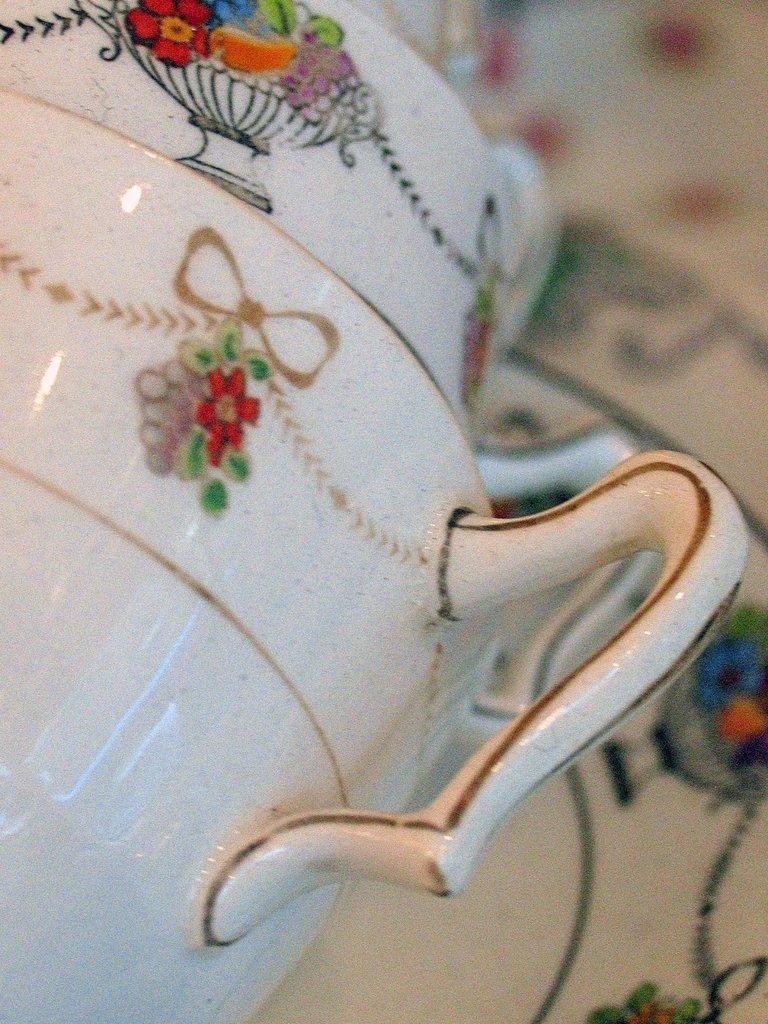What type of object is in the foreground of the image? There is a ceramic utensil in the foreground of the image. What language is being spoken by the toy during the rainstorm in the image? There is no toy or rainstorm present in the image, and therefore no such activity or language can be observed. 